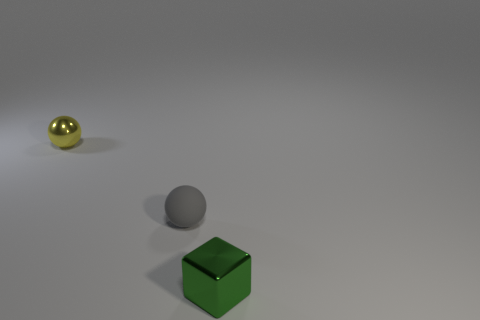Add 1 green matte cylinders. How many objects exist? 4 Subtract all blocks. How many objects are left? 2 Subtract 0 green cylinders. How many objects are left? 3 Subtract all tiny gray matte balls. Subtract all tiny yellow rubber cubes. How many objects are left? 2 Add 2 yellow objects. How many yellow objects are left? 3 Add 1 small red cylinders. How many small red cylinders exist? 1 